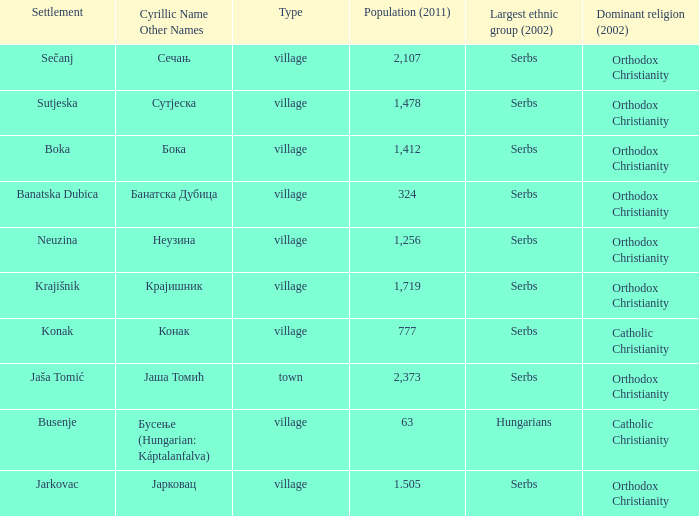What kind of type is  бока? Village. 